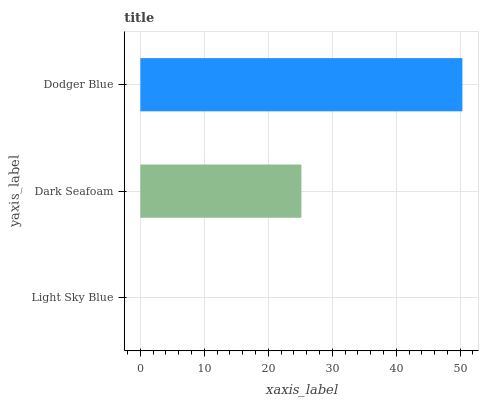Is Light Sky Blue the minimum?
Answer yes or no. Yes. Is Dodger Blue the maximum?
Answer yes or no. Yes. Is Dark Seafoam the minimum?
Answer yes or no. No. Is Dark Seafoam the maximum?
Answer yes or no. No. Is Dark Seafoam greater than Light Sky Blue?
Answer yes or no. Yes. Is Light Sky Blue less than Dark Seafoam?
Answer yes or no. Yes. Is Light Sky Blue greater than Dark Seafoam?
Answer yes or no. No. Is Dark Seafoam less than Light Sky Blue?
Answer yes or no. No. Is Dark Seafoam the high median?
Answer yes or no. Yes. Is Dark Seafoam the low median?
Answer yes or no. Yes. Is Light Sky Blue the high median?
Answer yes or no. No. Is Dodger Blue the low median?
Answer yes or no. No. 